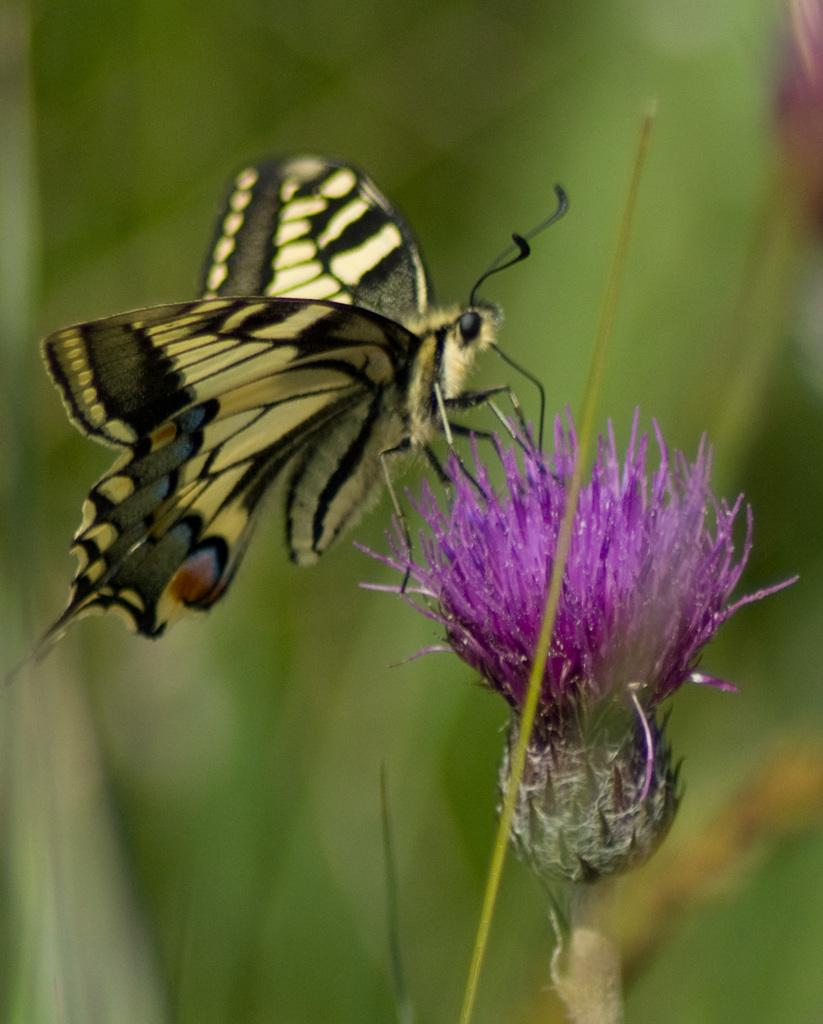What type of insect is in the image? There is a butterfly in the image. What colors can be seen on the butterfly? The butterfly has black, yellow, and brown colors. What other object is present in the image? There is a flower in the image. What color is the flower? The flower is purple. How would you describe the background of the image? The background of the image is blurry and has a green color. Can you tell me how many women are holding sheep in the image? There are no women or sheep present in the image; it features a butterfly and a flower. What is the thumbprint of the person who took the photo in the image? There is no thumbprint visible in the image, as it is a photograph of a butterfly and a flower. 